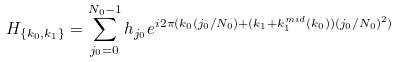<formula> <loc_0><loc_0><loc_500><loc_500>H _ { \{ k _ { 0 } , k _ { 1 } \} } = \sum _ { j _ { 0 } = 0 } ^ { N _ { 0 } - 1 } h _ { j _ { 0 } } e ^ { i 2 \pi ( k _ { 0 } ( j _ { 0 } / N _ { 0 } ) + ( k _ { 1 } + k _ { 1 } ^ { m i d } ( k _ { 0 } ) ) ( j _ { 0 } / N _ { 0 } ) ^ { 2 } ) }</formula> 